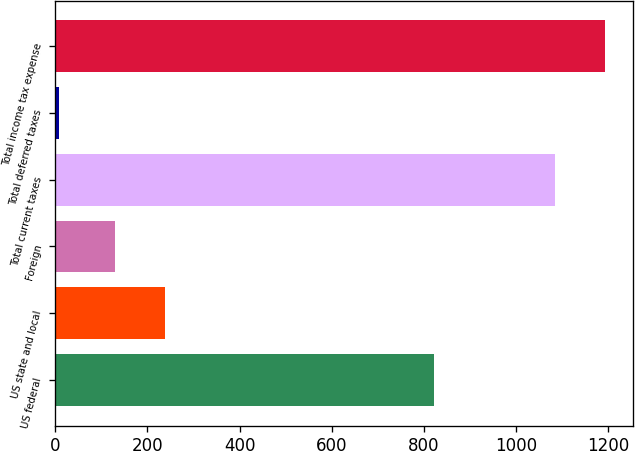<chart> <loc_0><loc_0><loc_500><loc_500><bar_chart><fcel>US federal<fcel>US state and local<fcel>Foreign<fcel>Total current taxes<fcel>Total deferred taxes<fcel>Total income tax expense<nl><fcel>822.7<fcel>237.24<fcel>128.8<fcel>1084.4<fcel>7.6<fcel>1192.84<nl></chart> 